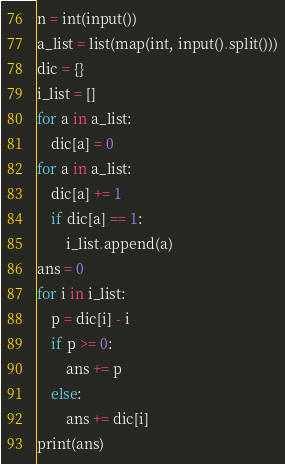<code> <loc_0><loc_0><loc_500><loc_500><_Python_>n = int(input())
a_list = list(map(int, input().split()))
dic = {}
i_list = []
for a in a_list:
    dic[a] = 0
for a in a_list:
    dic[a] += 1
    if dic[a] == 1:
        i_list.append(a)
ans = 0
for i in i_list:
    p = dic[i] - i 
    if p >= 0:
        ans += p
    else:
        ans += dic[i]
print(ans)</code> 